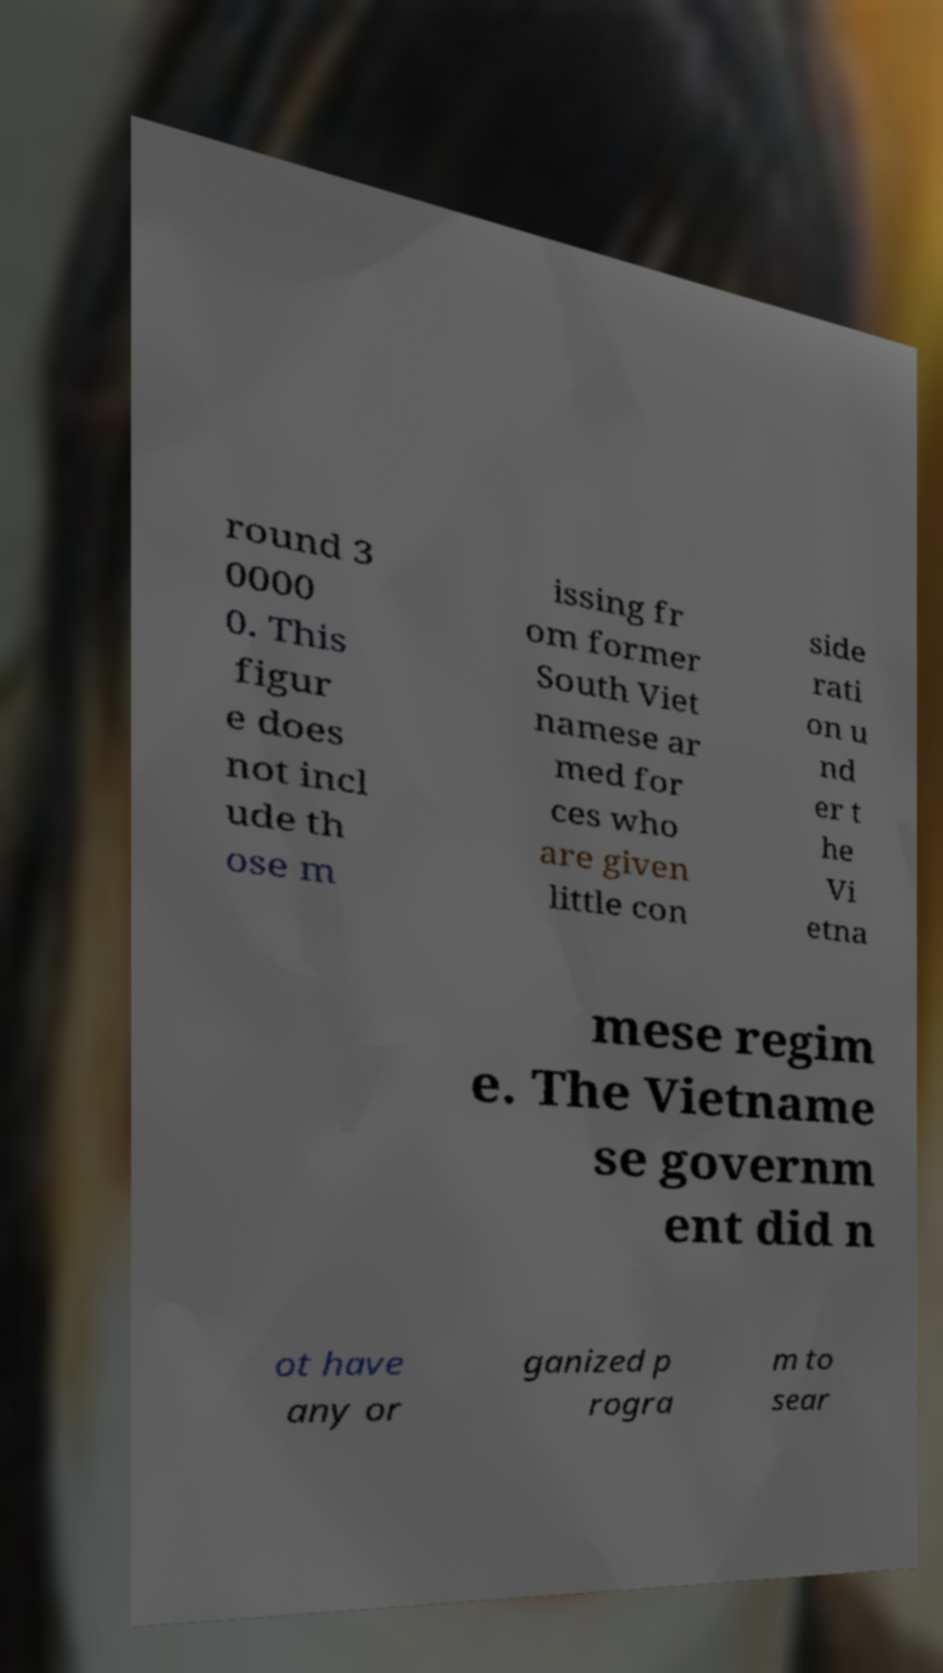There's text embedded in this image that I need extracted. Can you transcribe it verbatim? round 3 0000 0. This figur e does not incl ude th ose m issing fr om former South Viet namese ar med for ces who are given little con side rati on u nd er t he Vi etna mese regim e. The Vietname se governm ent did n ot have any or ganized p rogra m to sear 